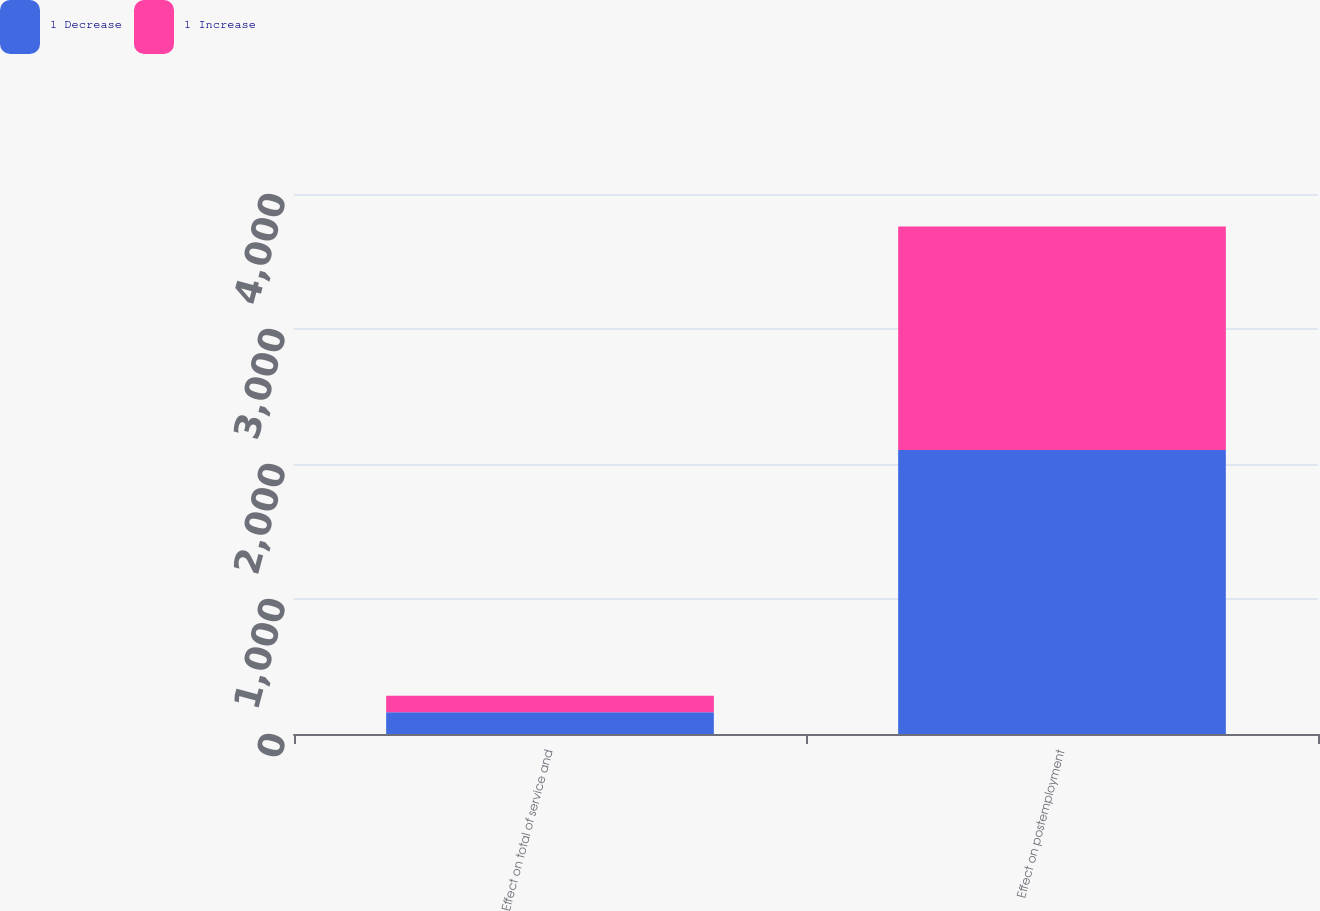Convert chart to OTSL. <chart><loc_0><loc_0><loc_500><loc_500><stacked_bar_chart><ecel><fcel>Effect on total of service and<fcel>Effect on postemployment<nl><fcel>1 Decrease<fcel>161<fcel>2104<nl><fcel>1 Increase<fcel>123<fcel>1656<nl></chart> 